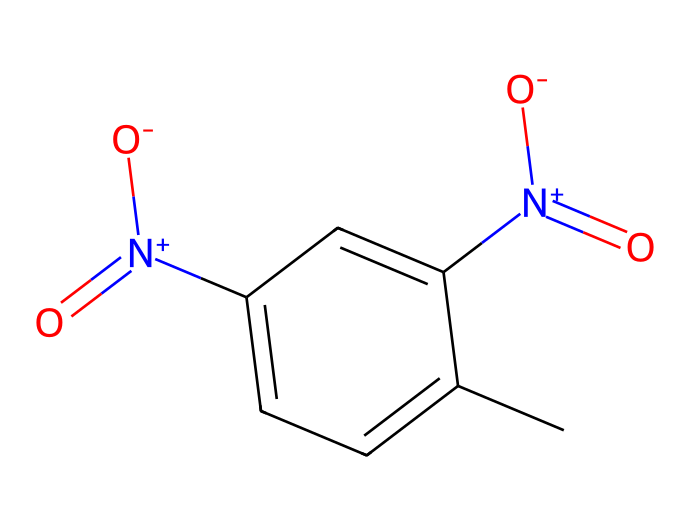What is the molecular formula of 2,4-Dinitrotoluene? The SMILES representation reveals the presence of carbon, hydrogen, nitrogen, and oxygen atoms. Counting the atoms gives us 7 carbon (C), 6 hydrogen (H), 4 nitrogen (N), and 4 oxygen (O) atoms. Therefore, the molecular formula is C7H6N4O4.
Answer: C7H6N4O4 How many nitro groups are present in the structure? The SMILES shows two instances of [N+](=O)[O-], indicating the presence of two nitro groups.
Answer: 2 What type of functional groups are present in this compound? The structure includes nitro groups (–NO2), which are characteristic of explosives, and has a methyl group (–CH3) attached to the aromatic ring. The presence of these groups identifies functional groups in the compound.
Answer: nitro and methyl What is the significance of the methyl group in 2,4-Dinitrotoluene? The methyl group contributes to the compound's identity as a derivative of toluene. It affects the chemical reactivity and properties of the molecule, influencing how it interacts in various chemical processes, especially in the context of explosive formation.
Answer: increases reactivity How do the positions of the nitro groups affect the reactivity of the compound? The positioning of the nitro groups (para and ortho positions) on the aromatic ring increases the electron-withdrawing effects, which can enhance the electrophilic substitution reactions. This can significantly alter the properties of the compound, especially in energetic materials.
Answer: increases electrophilicity What is the role of 2,4-Dinitrotoluene in smokeless powder production? 2,4-Dinitrotoluene acts as a precursor in the synthesis of smokeless powder, where its nitrated structure is crucial for creating a compound with desired explosive properties and stability.
Answer: precursor 